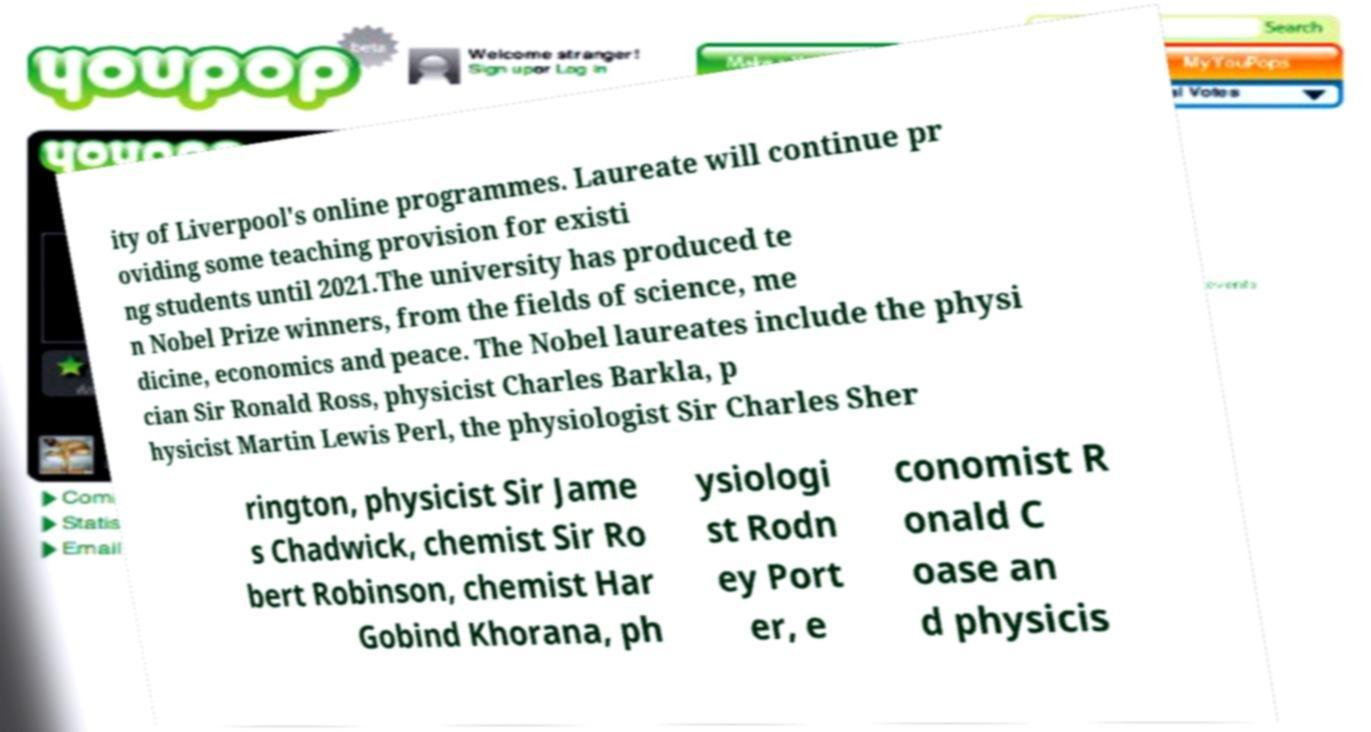Can you read and provide the text displayed in the image?This photo seems to have some interesting text. Can you extract and type it out for me? ity of Liverpool's online programmes. Laureate will continue pr oviding some teaching provision for existi ng students until 2021.The university has produced te n Nobel Prize winners, from the fields of science, me dicine, economics and peace. The Nobel laureates include the physi cian Sir Ronald Ross, physicist Charles Barkla, p hysicist Martin Lewis Perl, the physiologist Sir Charles Sher rington, physicist Sir Jame s Chadwick, chemist Sir Ro bert Robinson, chemist Har Gobind Khorana, ph ysiologi st Rodn ey Port er, e conomist R onald C oase an d physicis 